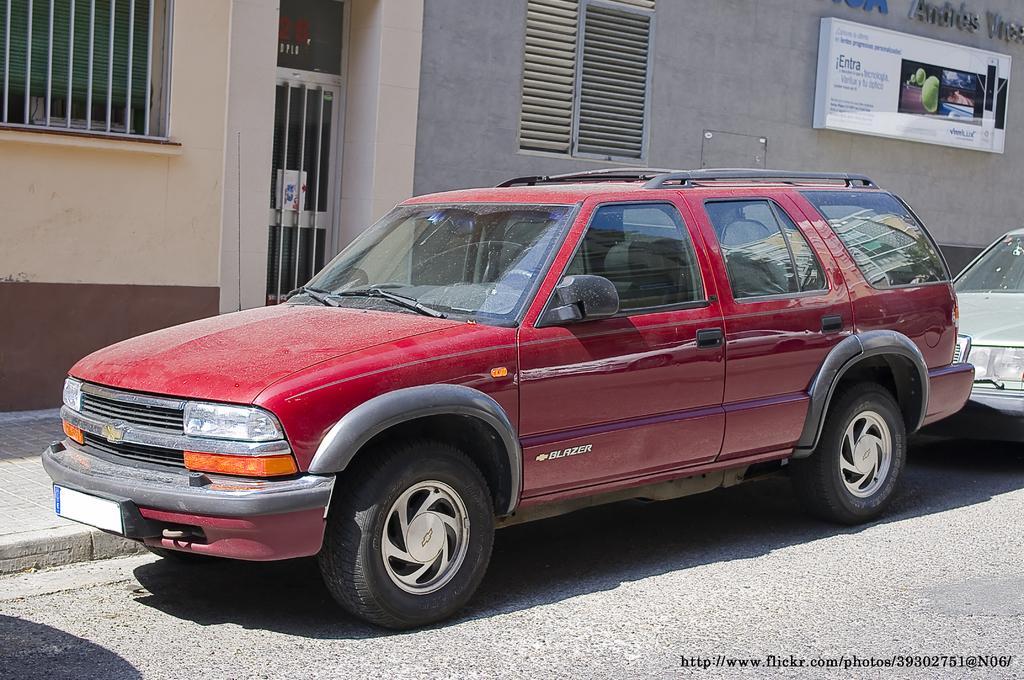Please provide a concise description of this image. In the center of the image there is a red color car parked on the road. In the background there is a building, a hoarding board to the building wall and also another car on the road. At the bottom there is logo. 